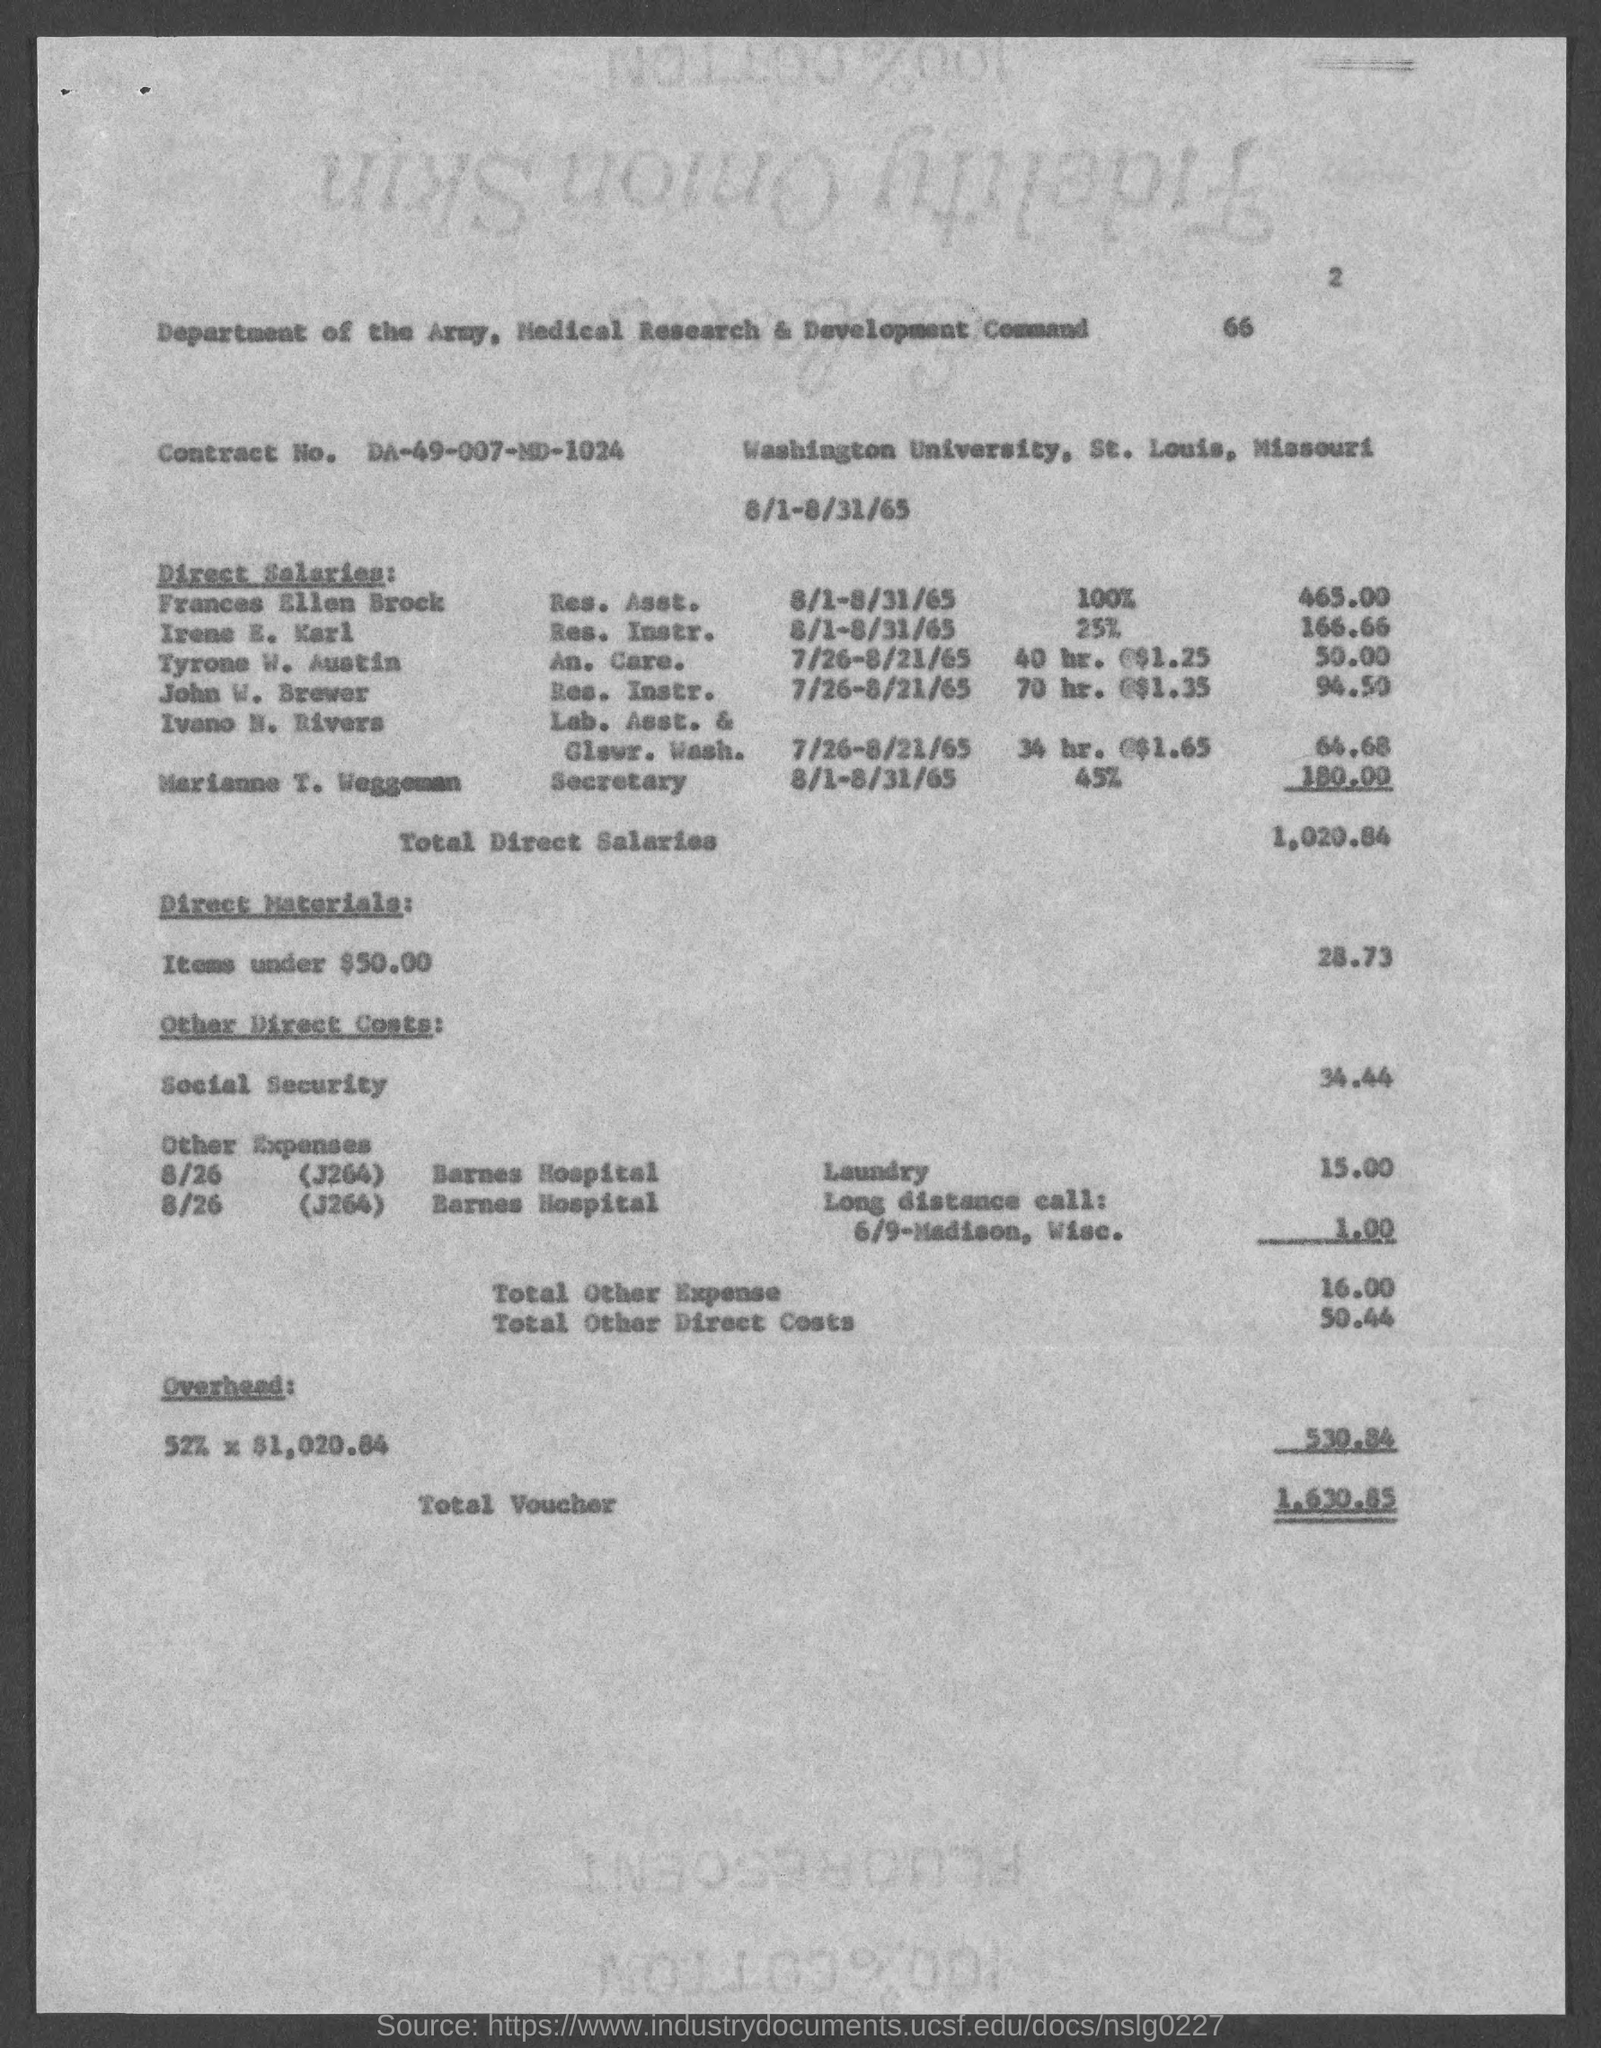Mention a couple of crucial points in this snapshot. Contract No. DA-49-007-MD-1024" is a reference to a contract with a specific number assigned to it. The total direct salaries are 1,020.84. The total voucher is 1,630.85. 